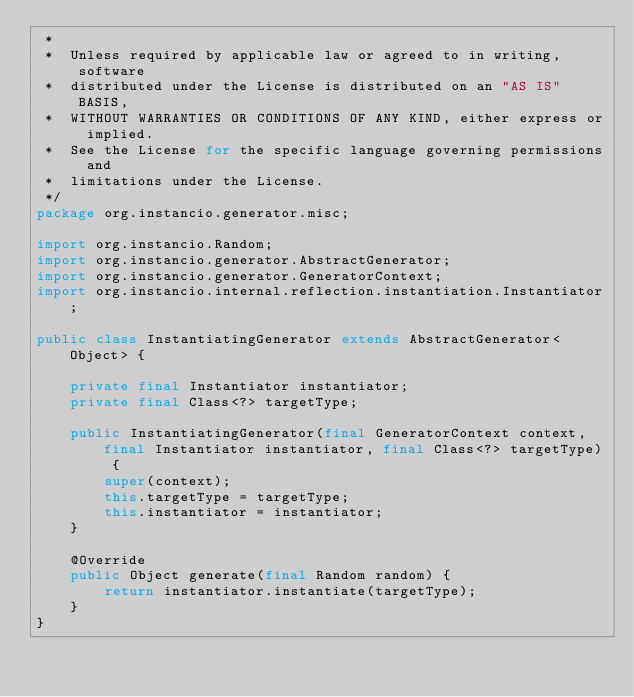<code> <loc_0><loc_0><loc_500><loc_500><_Java_> *
 *  Unless required by applicable law or agreed to in writing, software
 *  distributed under the License is distributed on an "AS IS" BASIS,
 *  WITHOUT WARRANTIES OR CONDITIONS OF ANY KIND, either express or implied.
 *  See the License for the specific language governing permissions and
 *  limitations under the License.
 */
package org.instancio.generator.misc;

import org.instancio.Random;
import org.instancio.generator.AbstractGenerator;
import org.instancio.generator.GeneratorContext;
import org.instancio.internal.reflection.instantiation.Instantiator;

public class InstantiatingGenerator extends AbstractGenerator<Object> {

    private final Instantiator instantiator;
    private final Class<?> targetType;

    public InstantiatingGenerator(final GeneratorContext context, final Instantiator instantiator, final Class<?> targetType) {
        super(context);
        this.targetType = targetType;
        this.instantiator = instantiator;
    }

    @Override
    public Object generate(final Random random) {
        return instantiator.instantiate(targetType);
    }
}
</code> 